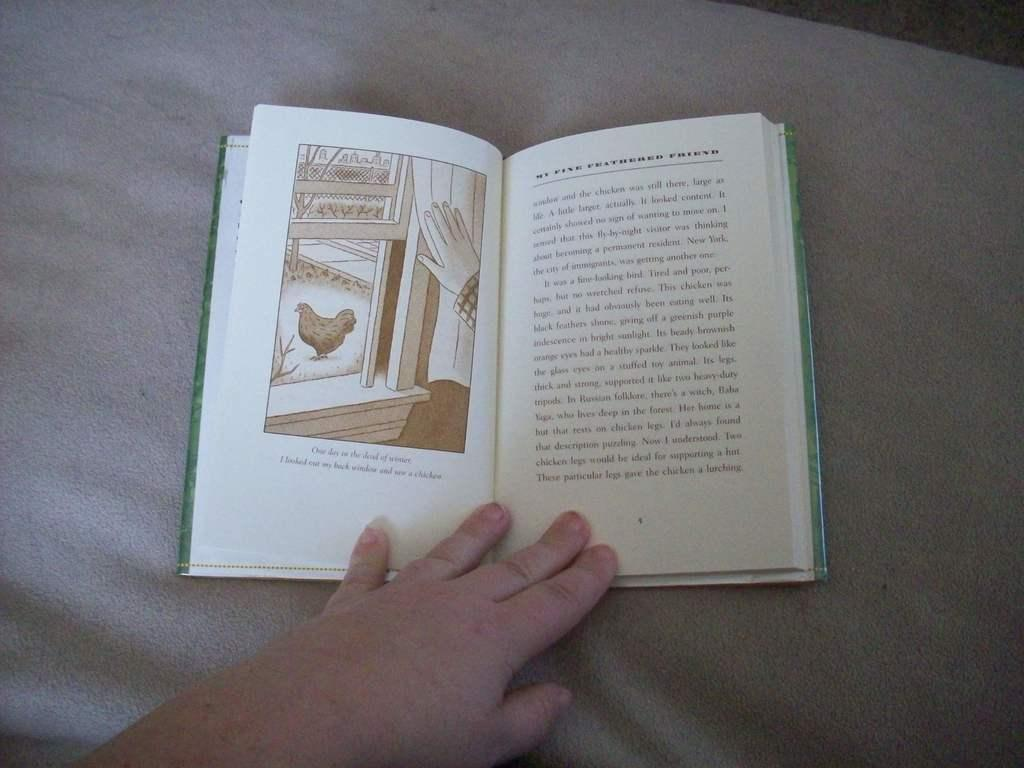<image>
Write a terse but informative summary of the picture. A book opened to a page with a window and a chicken that reads one day. 